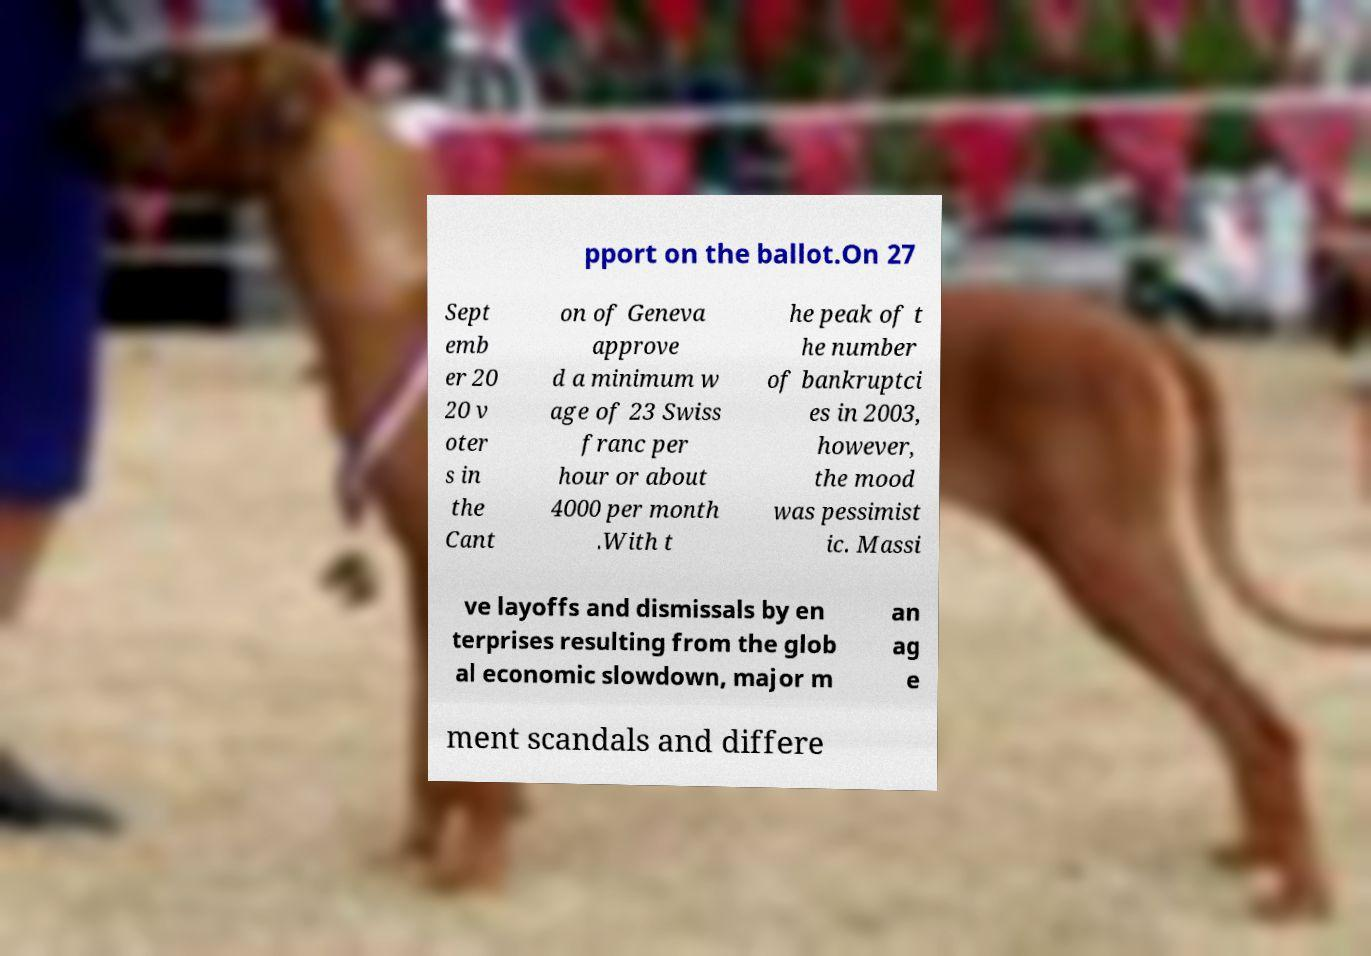I need the written content from this picture converted into text. Can you do that? pport on the ballot.On 27 Sept emb er 20 20 v oter s in the Cant on of Geneva approve d a minimum w age of 23 Swiss franc per hour or about 4000 per month .With t he peak of t he number of bankruptci es in 2003, however, the mood was pessimist ic. Massi ve layoffs and dismissals by en terprises resulting from the glob al economic slowdown, major m an ag e ment scandals and differe 